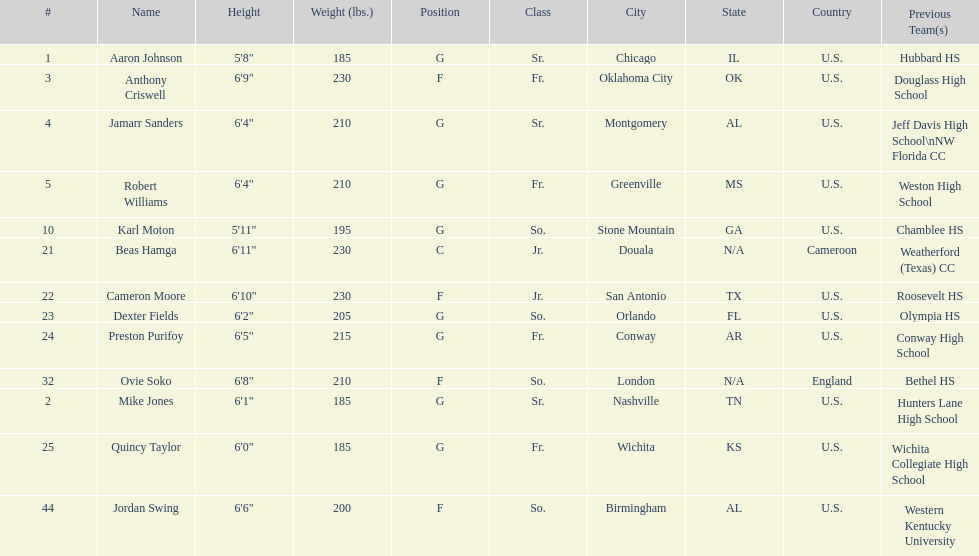What is the difference in weight between dexter fields and quincy taylor? 20. 